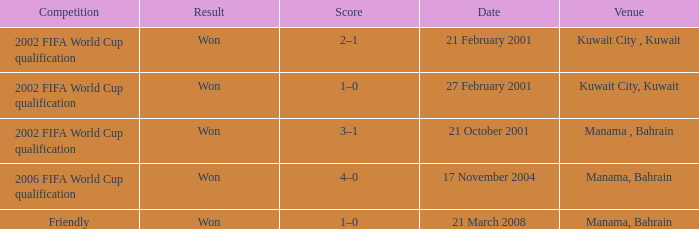On which date was the 2006 FIFA World Cup Qualification in Manama, Bahrain? 17 November 2004. 